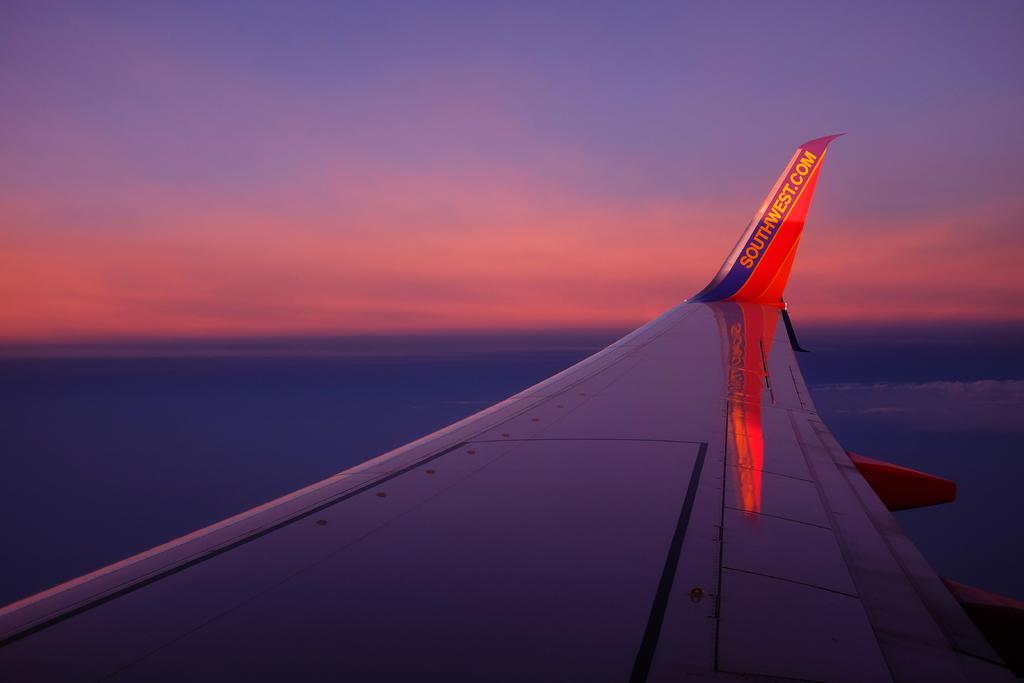<image>
Create a compact narrative representing the image presented. Southwest.com banner on a white airplane in the sky. 